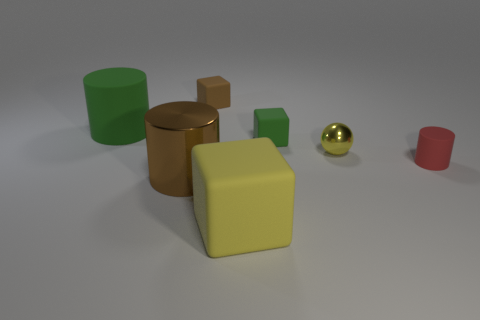Do the cube that is in front of the large brown cylinder and the brown thing that is in front of the tiny brown object have the same material?
Your response must be concise. No. What is the color of the large thing that is the same material as the yellow cube?
Give a very brief answer. Green. Is the number of small green rubber things that are behind the red thing greater than the number of small brown blocks left of the small brown rubber object?
Give a very brief answer. Yes. Is there a large metal cylinder?
Offer a terse response. Yes. There is a small sphere that is the same color as the large rubber cube; what material is it?
Make the answer very short. Metal. How many objects are tiny spheres or tiny brown blocks?
Your answer should be very brief. 2. Is there a small metal ball of the same color as the large cube?
Your answer should be compact. Yes. There is a yellow thing behind the big yellow cube; what number of yellow spheres are behind it?
Offer a very short reply. 0. Are there more green cylinders than big brown metallic blocks?
Your answer should be very brief. Yes. Do the small yellow object and the large green cylinder have the same material?
Ensure brevity in your answer.  No. 